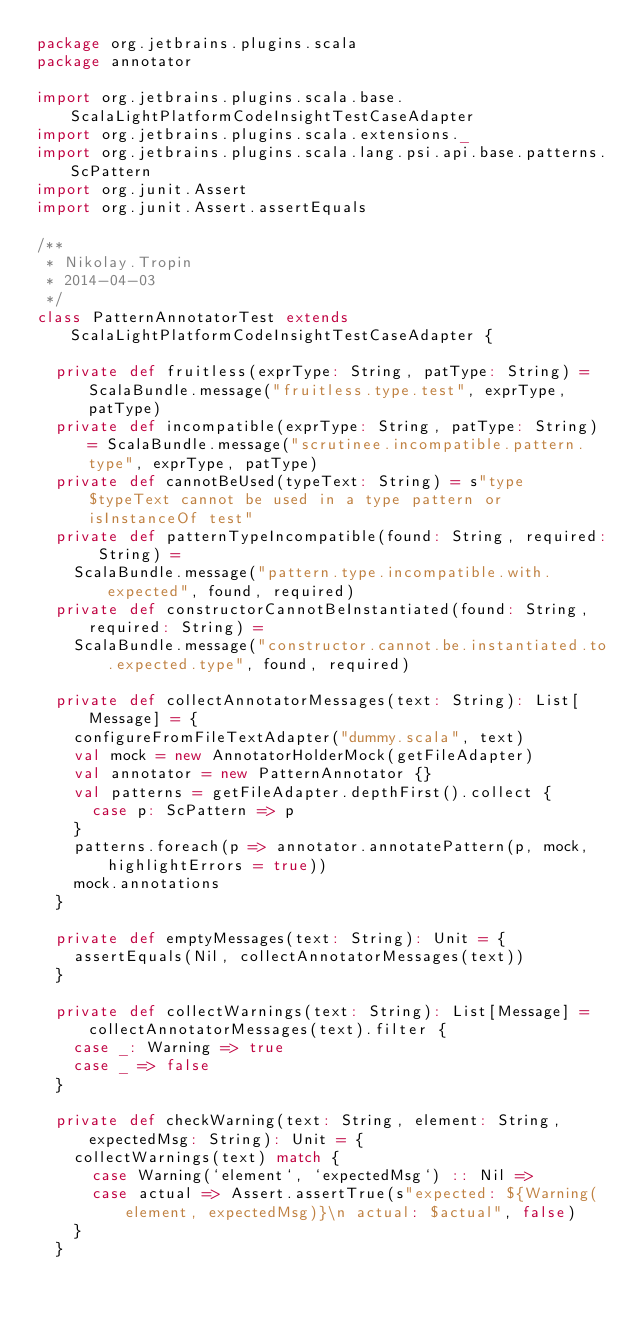<code> <loc_0><loc_0><loc_500><loc_500><_Scala_>package org.jetbrains.plugins.scala
package annotator

import org.jetbrains.plugins.scala.base.ScalaLightPlatformCodeInsightTestCaseAdapter
import org.jetbrains.plugins.scala.extensions._
import org.jetbrains.plugins.scala.lang.psi.api.base.patterns.ScPattern
import org.junit.Assert
import org.junit.Assert.assertEquals

/**
 * Nikolay.Tropin
 * 2014-04-03
 */
class PatternAnnotatorTest extends ScalaLightPlatformCodeInsightTestCaseAdapter {

  private def fruitless(exprType: String, patType: String) = ScalaBundle.message("fruitless.type.test", exprType, patType)
  private def incompatible(exprType: String, patType: String) = ScalaBundle.message("scrutinee.incompatible.pattern.type", exprType, patType)
  private def cannotBeUsed(typeText: String) = s"type $typeText cannot be used in a type pattern or isInstanceOf test"
  private def patternTypeIncompatible(found: String, required: String) =
    ScalaBundle.message("pattern.type.incompatible.with.expected", found, required)
  private def constructorCannotBeInstantiated(found: String, required: String) =
    ScalaBundle.message("constructor.cannot.be.instantiated.to.expected.type", found, required)

  private def collectAnnotatorMessages(text: String): List[Message] = {
    configureFromFileTextAdapter("dummy.scala", text)
    val mock = new AnnotatorHolderMock(getFileAdapter)
    val annotator = new PatternAnnotator {}
    val patterns = getFileAdapter.depthFirst().collect {
      case p: ScPattern => p
    }
    patterns.foreach(p => annotator.annotatePattern(p, mock, highlightErrors = true))
    mock.annotations
  }

  private def emptyMessages(text: String): Unit = {
    assertEquals(Nil, collectAnnotatorMessages(text))
  }

  private def collectWarnings(text: String): List[Message] = collectAnnotatorMessages(text).filter {
    case _: Warning => true
    case _ => false
  }

  private def checkWarning(text: String, element: String, expectedMsg: String): Unit = {
    collectWarnings(text) match {
      case Warning(`element`, `expectedMsg`) :: Nil =>
      case actual => Assert.assertTrue(s"expected: ${Warning(element, expectedMsg)}\n actual: $actual", false)
    }
  }
</code> 